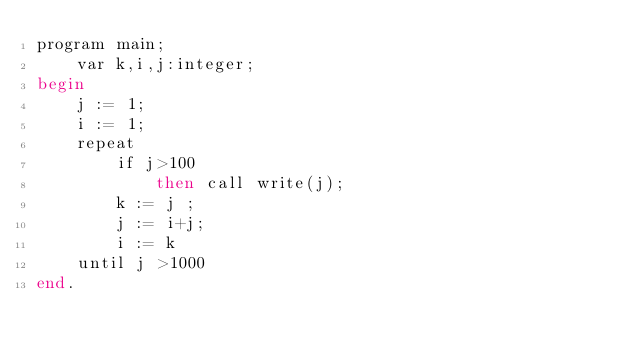<code> <loc_0><loc_0><loc_500><loc_500><_SQL_>program main;
    var k,i,j:integer;
begin
    j := 1;
    i := 1;
    repeat
        if j>100
            then call write(j);
        k := j ;
        j := i+j;
        i := k
    until j >1000
end.
</code> 